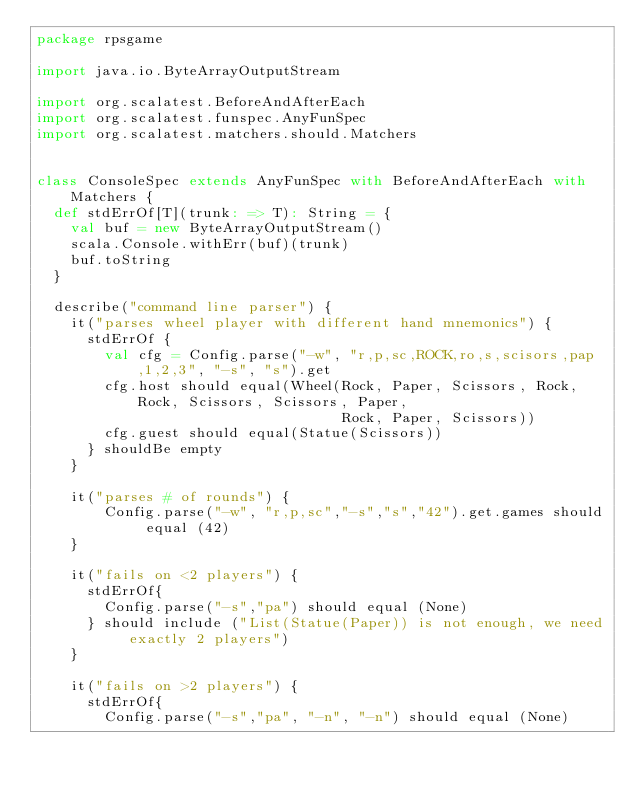<code> <loc_0><loc_0><loc_500><loc_500><_Scala_>package rpsgame

import java.io.ByteArrayOutputStream

import org.scalatest.BeforeAndAfterEach
import org.scalatest.funspec.AnyFunSpec
import org.scalatest.matchers.should.Matchers


class ConsoleSpec extends AnyFunSpec with BeforeAndAfterEach with Matchers {
  def stdErrOf[T](trunk: => T): String = {
    val buf = new ByteArrayOutputStream()
    scala.Console.withErr(buf)(trunk)
    buf.toString
  }

  describe("command line parser") {
    it("parses wheel player with different hand mnemonics") {
      stdErrOf {
        val cfg = Config.parse("-w", "r,p,sc,ROCK,ro,s,scisors,pap,1,2,3", "-s", "s").get
        cfg.host should equal(Wheel(Rock, Paper, Scissors, Rock, Rock, Scissors, Scissors, Paper,
                                    Rock, Paper, Scissors))
        cfg.guest should equal(Statue(Scissors))
      } shouldBe empty
    }

    it("parses # of rounds") {
        Config.parse("-w", "r,p,sc","-s","s","42").get.games should equal (42)
    }

    it("fails on <2 players") {
      stdErrOf{
        Config.parse("-s","pa") should equal (None)
      } should include ("List(Statue(Paper)) is not enough, we need exactly 2 players")
    }

    it("fails on >2 players") {
      stdErrOf{
        Config.parse("-s","pa", "-n", "-n") should equal (None)</code> 